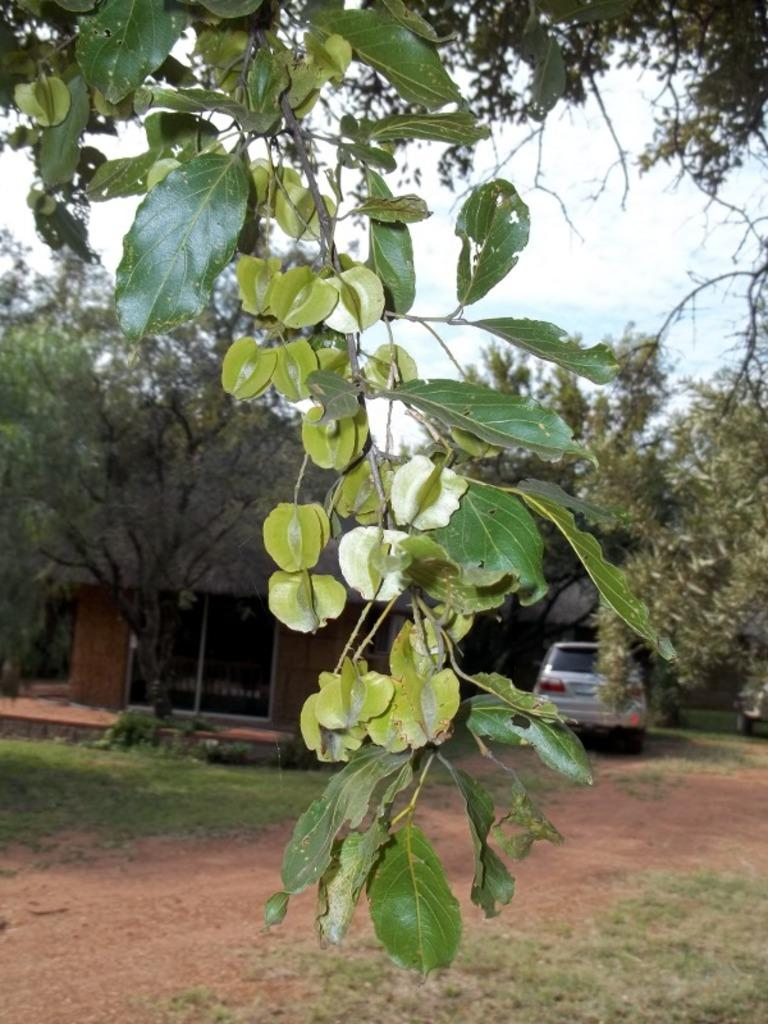What type of vegetation can be seen in the image? There are trees in the image. What is on the ground in the image? There is grass on the ground in the image. What mode of transportation is present in the image? There is a car in the image. What type of structure can be seen in the image? There is a building in the image. How many dolls are sitting under the umbrella in the image? There are no dolls or umbrellas present in the image. What type of animal can be seen interacting with the car in the image? There are no animals present in the image, and the car is not interacting with any objects or subjects. 